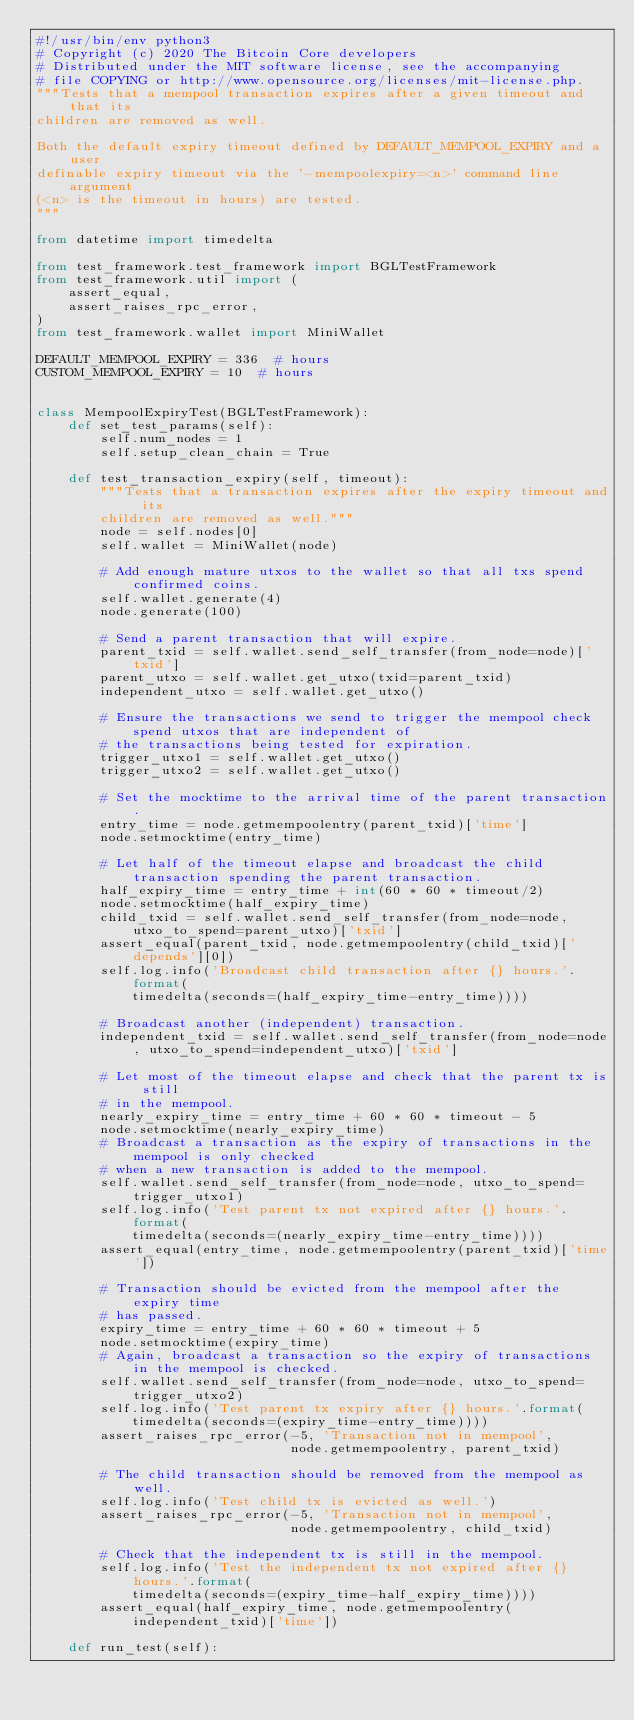<code> <loc_0><loc_0><loc_500><loc_500><_Python_>#!/usr/bin/env python3
# Copyright (c) 2020 The Bitcoin Core developers
# Distributed under the MIT software license, see the accompanying
# file COPYING or http://www.opensource.org/licenses/mit-license.php.
"""Tests that a mempool transaction expires after a given timeout and that its
children are removed as well.

Both the default expiry timeout defined by DEFAULT_MEMPOOL_EXPIRY and a user
definable expiry timeout via the '-mempoolexpiry=<n>' command line argument
(<n> is the timeout in hours) are tested.
"""

from datetime import timedelta

from test_framework.test_framework import BGLTestFramework
from test_framework.util import (
    assert_equal,
    assert_raises_rpc_error,
)
from test_framework.wallet import MiniWallet

DEFAULT_MEMPOOL_EXPIRY = 336  # hours
CUSTOM_MEMPOOL_EXPIRY = 10  # hours


class MempoolExpiryTest(BGLTestFramework):
    def set_test_params(self):
        self.num_nodes = 1
        self.setup_clean_chain = True

    def test_transaction_expiry(self, timeout):
        """Tests that a transaction expires after the expiry timeout and its
        children are removed as well."""
        node = self.nodes[0]
        self.wallet = MiniWallet(node)

        # Add enough mature utxos to the wallet so that all txs spend confirmed coins.
        self.wallet.generate(4)
        node.generate(100)

        # Send a parent transaction that will expire.
        parent_txid = self.wallet.send_self_transfer(from_node=node)['txid']
        parent_utxo = self.wallet.get_utxo(txid=parent_txid)
        independent_utxo = self.wallet.get_utxo()

        # Ensure the transactions we send to trigger the mempool check spend utxos that are independent of
        # the transactions being tested for expiration.
        trigger_utxo1 = self.wallet.get_utxo()
        trigger_utxo2 = self.wallet.get_utxo()

        # Set the mocktime to the arrival time of the parent transaction.
        entry_time = node.getmempoolentry(parent_txid)['time']
        node.setmocktime(entry_time)

        # Let half of the timeout elapse and broadcast the child transaction spending the parent transaction.
        half_expiry_time = entry_time + int(60 * 60 * timeout/2)
        node.setmocktime(half_expiry_time)
        child_txid = self.wallet.send_self_transfer(from_node=node, utxo_to_spend=parent_utxo)['txid']
        assert_equal(parent_txid, node.getmempoolentry(child_txid)['depends'][0])
        self.log.info('Broadcast child transaction after {} hours.'.format(
            timedelta(seconds=(half_expiry_time-entry_time))))

        # Broadcast another (independent) transaction.
        independent_txid = self.wallet.send_self_transfer(from_node=node, utxo_to_spend=independent_utxo)['txid']

        # Let most of the timeout elapse and check that the parent tx is still
        # in the mempool.
        nearly_expiry_time = entry_time + 60 * 60 * timeout - 5
        node.setmocktime(nearly_expiry_time)
        # Broadcast a transaction as the expiry of transactions in the mempool is only checked
        # when a new transaction is added to the mempool.
        self.wallet.send_self_transfer(from_node=node, utxo_to_spend=trigger_utxo1)
        self.log.info('Test parent tx not expired after {} hours.'.format(
            timedelta(seconds=(nearly_expiry_time-entry_time))))
        assert_equal(entry_time, node.getmempoolentry(parent_txid)['time'])

        # Transaction should be evicted from the mempool after the expiry time
        # has passed.
        expiry_time = entry_time + 60 * 60 * timeout + 5
        node.setmocktime(expiry_time)
        # Again, broadcast a transaction so the expiry of transactions in the mempool is checked.
        self.wallet.send_self_transfer(from_node=node, utxo_to_spend=trigger_utxo2)
        self.log.info('Test parent tx expiry after {} hours.'.format(
            timedelta(seconds=(expiry_time-entry_time))))
        assert_raises_rpc_error(-5, 'Transaction not in mempool',
                                node.getmempoolentry, parent_txid)

        # The child transaction should be removed from the mempool as well.
        self.log.info('Test child tx is evicted as well.')
        assert_raises_rpc_error(-5, 'Transaction not in mempool',
                                node.getmempoolentry, child_txid)

        # Check that the independent tx is still in the mempool.
        self.log.info('Test the independent tx not expired after {} hours.'.format(
            timedelta(seconds=(expiry_time-half_expiry_time))))
        assert_equal(half_expiry_time, node.getmempoolentry(independent_txid)['time'])

    def run_test(self):</code> 